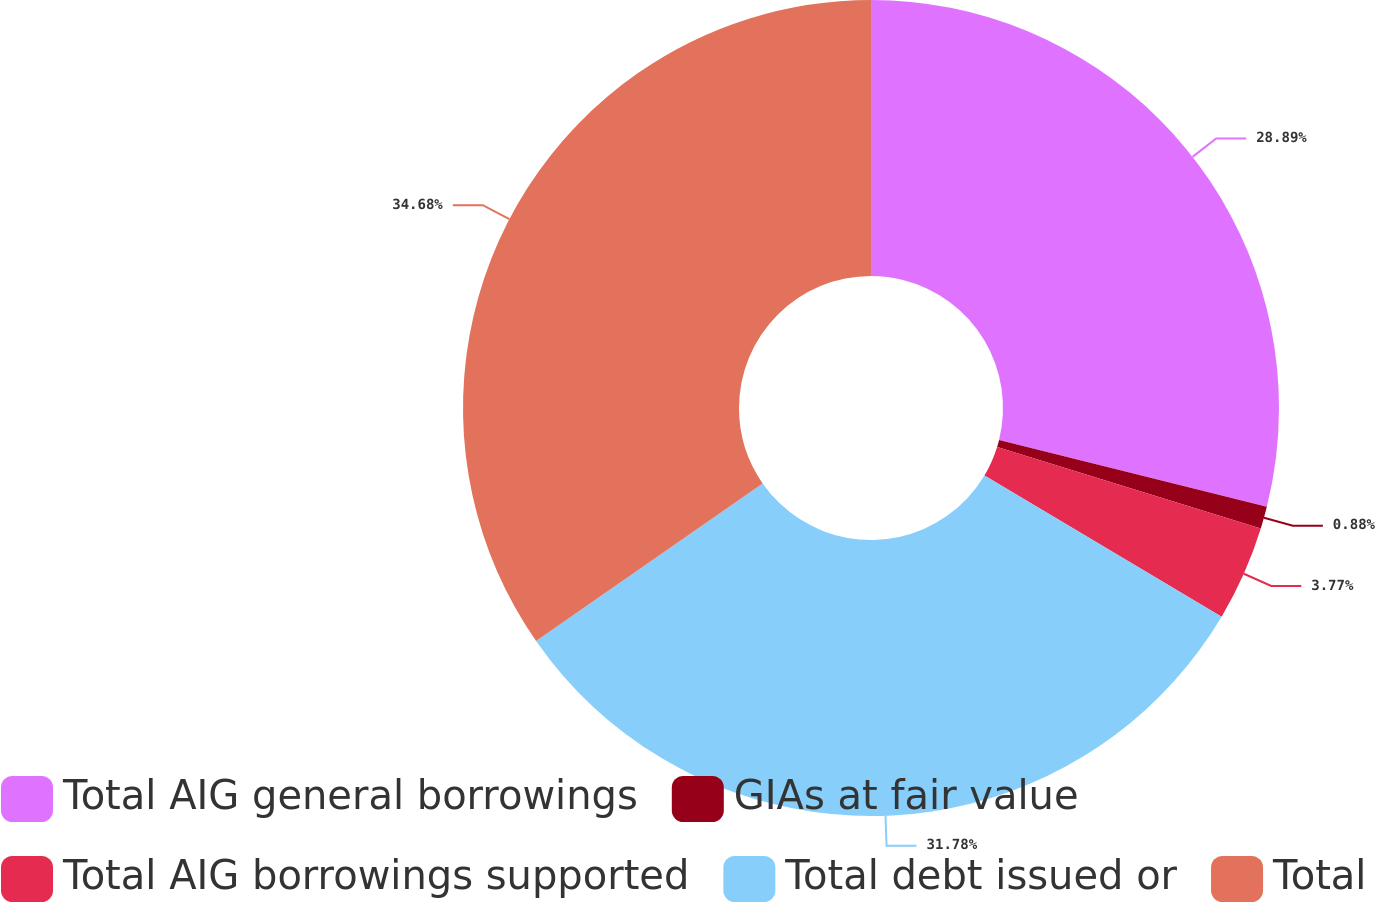<chart> <loc_0><loc_0><loc_500><loc_500><pie_chart><fcel>Total AIG general borrowings<fcel>GIAs at fair value<fcel>Total AIG borrowings supported<fcel>Total debt issued or<fcel>Total<nl><fcel>28.89%<fcel>0.88%<fcel>3.77%<fcel>31.78%<fcel>34.67%<nl></chart> 